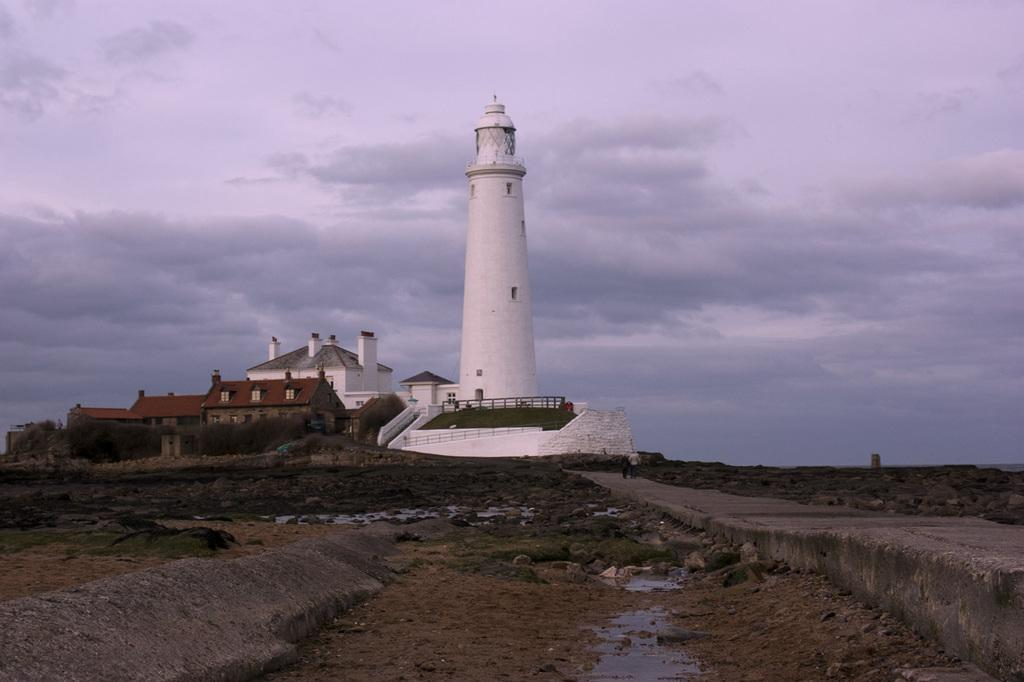What type of structure is present in the image? There is a building with a tower in the image. What are the people in the image doing? People are walking on the road in the image. What is located at the bottom of the image? There is an open area at the bottom of the image. What is visible at the top of the image? The sky is visible at the top of the image. Can you hear a whistle in the image? There is no auditory information provided in the image, so it is impossible to determine if a whistle can be heard. Is there a flame visible in the image? There is no flame present in the image. 